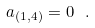Convert formula to latex. <formula><loc_0><loc_0><loc_500><loc_500>a _ { ( 1 , 4 ) } = 0 \ .</formula> 